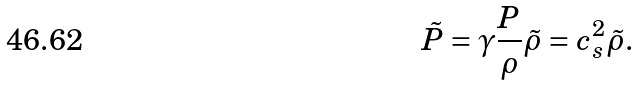<formula> <loc_0><loc_0><loc_500><loc_500>\tilde { P } = \gamma \frac { P } { \rho } \tilde { \rho } = c _ { s } ^ { 2 } \tilde { \rho } .</formula> 